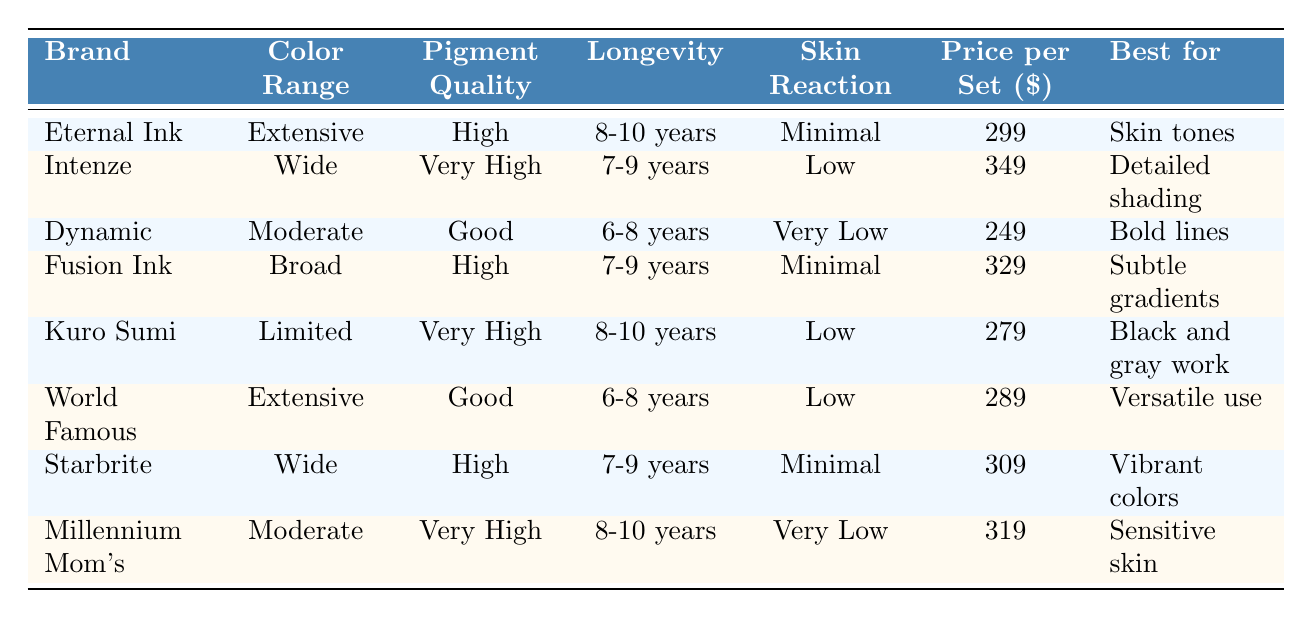What is the price of Eternal Ink per set? The table lists the price per set for Eternal Ink as 299 dollars.
Answer: 299 Which brand offers the widest color range? According to the table, both Eternal Ink and World Famous have an "Extensive" color range, indicating they offer a wide variety of colors.
Answer: Eternal Ink and World Famous What is the longevity of Kuro Sumi ink? The longevity for Kuro Sumi ink is stated in the table as 8-10 years.
Answer: 8-10 years Is Dynamic ink suitable for detailed shading? The table indicates that Dynamic ink is best for bold lines, which implies it is not suitable for detailed shading.
Answer: No Which brand has the highest pigment quality? According to the table, Intenze and Kuro Sumi both have "Very High" pigment quality, making them the top performers in this category.
Answer: Intenze and Kuro Sumi What is the average price per set of the four brands that have high pigment quality? The brands with high pigment quality are Eternal Ink, Fusion Ink, Starbrite, and Kuro Sumi with respective prices 299, 329, 309, and 279. The average is calculated as (299 + 329 + 309 + 279) / 4 = 304.5.
Answer: 304.5 Which brand has the lowest skin reaction concern? Dynamic has "Very Low" skin reaction concern, making it the brand with the least concern for skin reactions.
Answer: Dynamic How does the color range of Millennium Mom's compare to other brands? Millennium Mom's has a "Moderate" color range, while most other brands listed either have "Extensive," "Wide," or "Broad," indicating that it offers fewer options in comparison.
Answer: Moderate Which brand is best for sensitive skin? The table specifies that Millennium Mom's is best for sensitive skin, indicating its formulation is less likely to cause reactions.
Answer: Millennium Mom's If a tattoo artist wants to create subtle gradients, which ink should they use? The table shows that Fusion Ink is best for subtle gradients, making it the recommended choice for that purpose.
Answer: Fusion Ink 